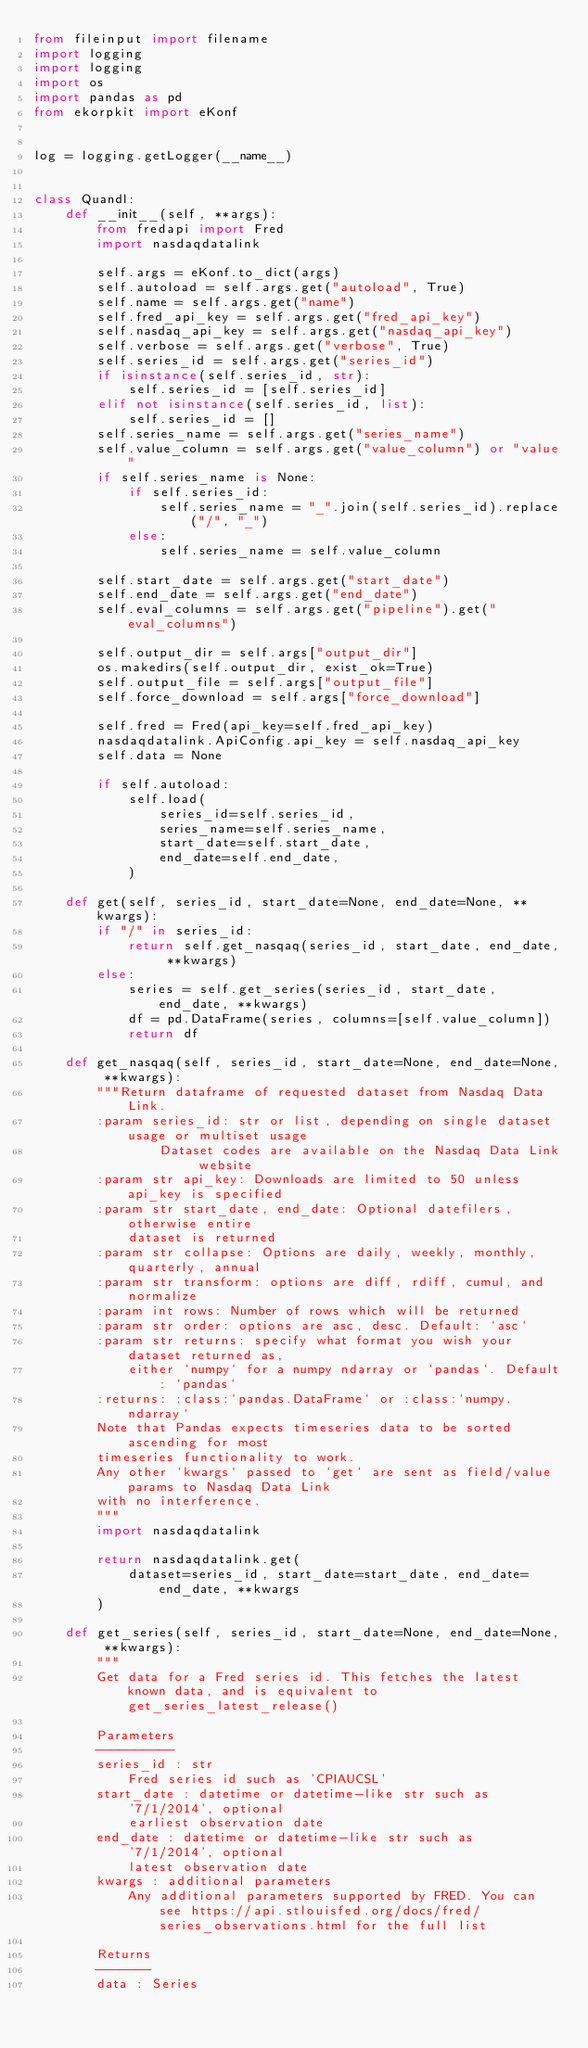<code> <loc_0><loc_0><loc_500><loc_500><_Python_>from fileinput import filename
import logging
import logging
import os
import pandas as pd
from ekorpkit import eKonf


log = logging.getLogger(__name__)


class Quandl:
    def __init__(self, **args):
        from fredapi import Fred
        import nasdaqdatalink

        self.args = eKonf.to_dict(args)
        self.autoload = self.args.get("autoload", True)
        self.name = self.args.get("name")
        self.fred_api_key = self.args.get("fred_api_key")
        self.nasdaq_api_key = self.args.get("nasdaq_api_key")
        self.verbose = self.args.get("verbose", True)
        self.series_id = self.args.get("series_id")
        if isinstance(self.series_id, str):
            self.series_id = [self.series_id]
        elif not isinstance(self.series_id, list):
            self.series_id = []
        self.series_name = self.args.get("series_name")
        self.value_column = self.args.get("value_column") or "value"
        if self.series_name is None:
            if self.series_id:
                self.series_name = "_".join(self.series_id).replace("/", "_")
            else:
                self.series_name = self.value_column

        self.start_date = self.args.get("start_date")
        self.end_date = self.args.get("end_date")
        self.eval_columns = self.args.get("pipeline").get("eval_columns")

        self.output_dir = self.args["output_dir"]
        os.makedirs(self.output_dir, exist_ok=True)
        self.output_file = self.args["output_file"]
        self.force_download = self.args["force_download"]

        self.fred = Fred(api_key=self.fred_api_key)
        nasdaqdatalink.ApiConfig.api_key = self.nasdaq_api_key
        self.data = None

        if self.autoload:
            self.load(
                series_id=self.series_id,
                series_name=self.series_name,
                start_date=self.start_date,
                end_date=self.end_date,
            )

    def get(self, series_id, start_date=None, end_date=None, **kwargs):
        if "/" in series_id:
            return self.get_nasqaq(series_id, start_date, end_date, **kwargs)
        else:
            series = self.get_series(series_id, start_date, end_date, **kwargs)
            df = pd.DataFrame(series, columns=[self.value_column])
            return df

    def get_nasqaq(self, series_id, start_date=None, end_date=None, **kwargs):
        """Return dataframe of requested dataset from Nasdaq Data Link.
        :param series_id: str or list, depending on single dataset usage or multiset usage
                Dataset codes are available on the Nasdaq Data Link website
        :param str api_key: Downloads are limited to 50 unless api_key is specified
        :param str start_date, end_date: Optional datefilers, otherwise entire
            dataset is returned
        :param str collapse: Options are daily, weekly, monthly, quarterly, annual
        :param str transform: options are diff, rdiff, cumul, and normalize
        :param int rows: Number of rows which will be returned
        :param str order: options are asc, desc. Default: `asc`
        :param str returns: specify what format you wish your dataset returned as,
            either `numpy` for a numpy ndarray or `pandas`. Default: `pandas`
        :returns: :class:`pandas.DataFrame` or :class:`numpy.ndarray`
        Note that Pandas expects timeseries data to be sorted ascending for most
        timeseries functionality to work.
        Any other `kwargs` passed to `get` are sent as field/value params to Nasdaq Data Link
        with no interference.
        """
        import nasdaqdatalink

        return nasdaqdatalink.get(
            dataset=series_id, start_date=start_date, end_date=end_date, **kwargs
        )

    def get_series(self, series_id, start_date=None, end_date=None, **kwargs):
        """
        Get data for a Fred series id. This fetches the latest known data, and is equivalent to get_series_latest_release()

        Parameters
        ----------
        series_id : str
            Fred series id such as 'CPIAUCSL'
        start_date : datetime or datetime-like str such as '7/1/2014', optional
            earliest observation date
        end_date : datetime or datetime-like str such as '7/1/2014', optional
            latest observation date
        kwargs : additional parameters
            Any additional parameters supported by FRED. You can see https://api.stlouisfed.org/docs/fred/series_observations.html for the full list

        Returns
        -------
        data : Series</code> 